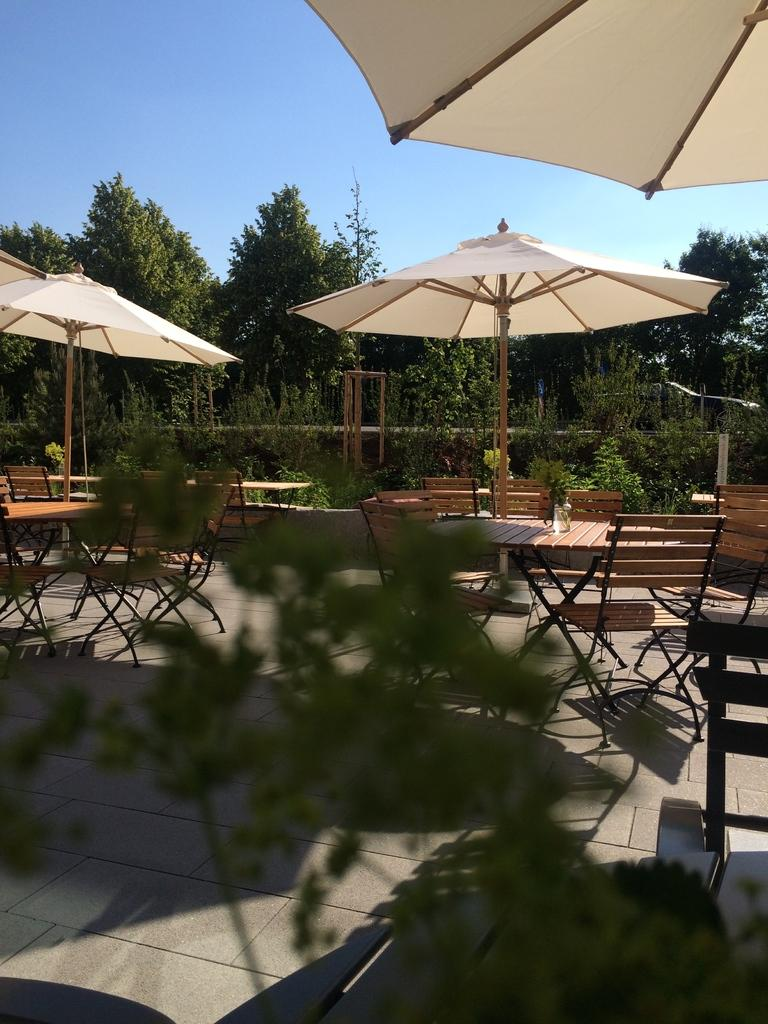What type of living organism can be seen in the image? There is a plant in the image. What objects are present for protection from the sun or rain? There are umbrellas in the image. What type of furniture is visible in the image? There are tables and chairs in the image. What can be seen in the background of the image? There are trees in the background of the image. Where is the jewel hidden in the image? There is no mention of a jewel in the image, so it cannot be hidden or present. 